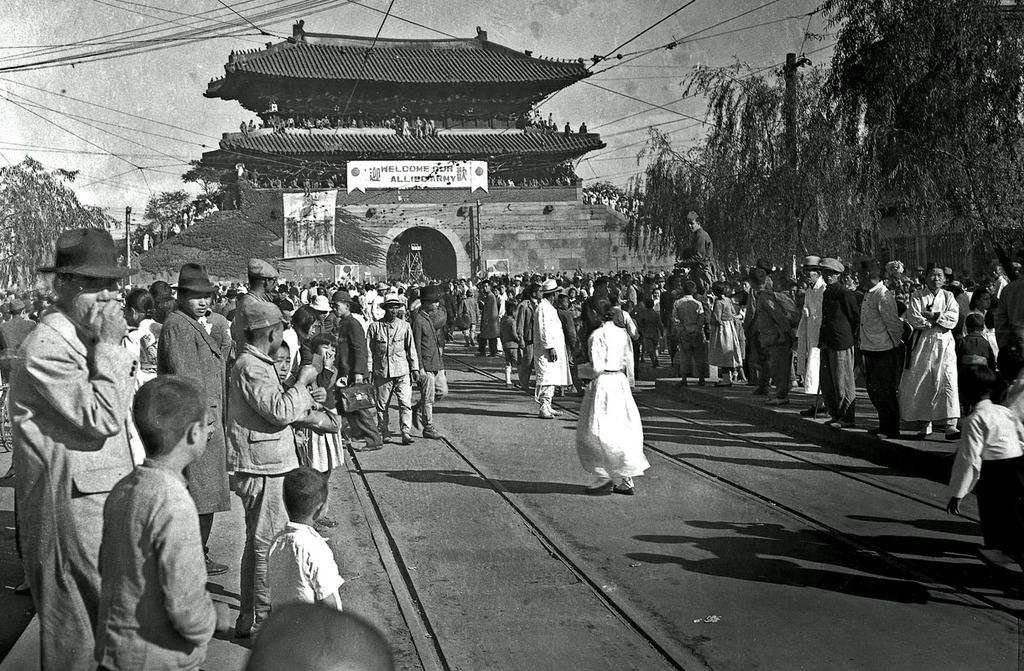What is happening on the road in the image? There is a group of people on the road in the image. What can be seen in the background of the image? There is a building in the image, and the sky is visible in the background. What type of structures are present in the image? There are posters, trees, electric poles, and wires in the image. Can you hear the toys laughing in the image? There are no toys present in the image, so it is not possible to hear them laughing. 